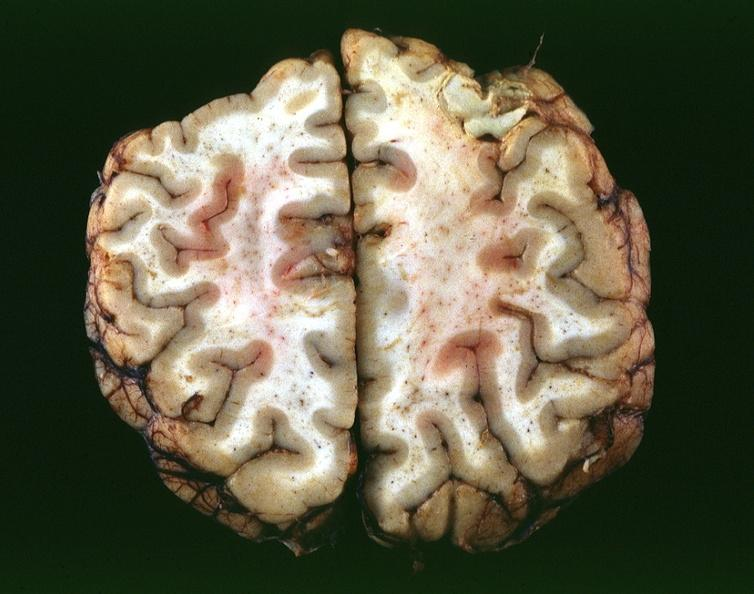s nervous present?
Answer the question using a single word or phrase. Yes 